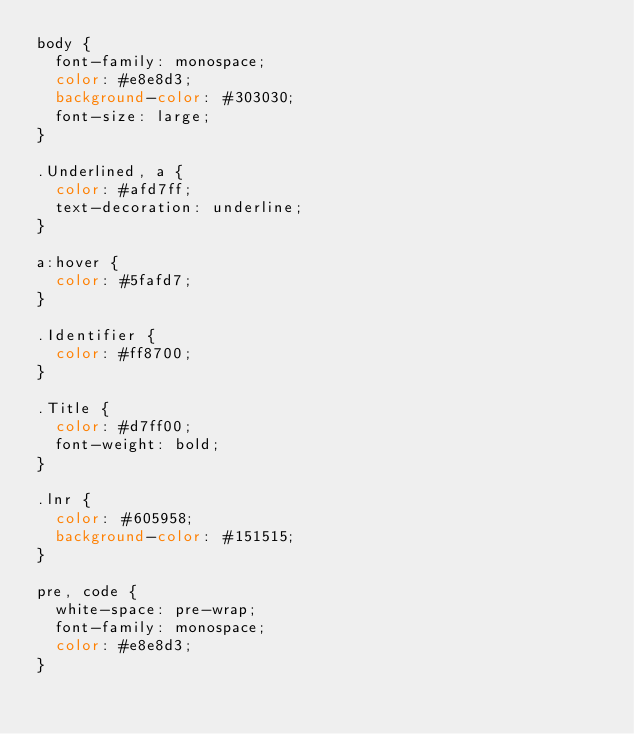Convert code to text. <code><loc_0><loc_0><loc_500><loc_500><_CSS_>body {
  font-family: monospace;
  color: #e8e8d3;
  background-color: #303030;
  font-size: large;
}

.Underlined, a {
  color: #afd7ff;
  text-decoration: underline;
}

a:hover {
  color: #5fafd7;
}

.Identifier {
  color: #ff8700;
}

.Title {
  color: #d7ff00;
  font-weight: bold;
}

.lnr {
  color: #605958;
  background-color: #151515;
}

pre, code {
  white-space: pre-wrap;
  font-family: monospace;
  color: #e8e8d3;
}

</code> 